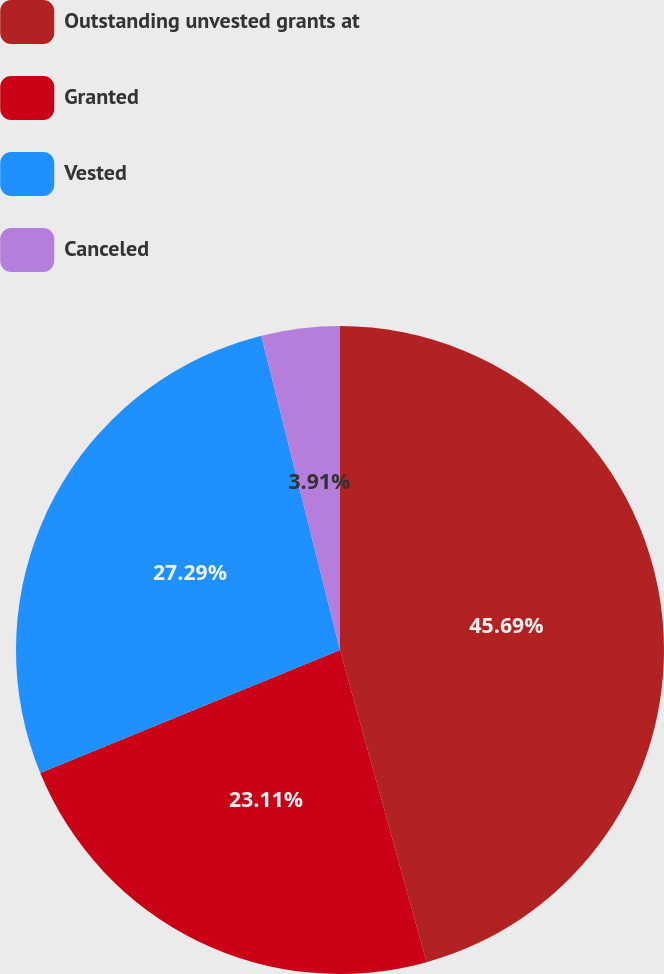Convert chart. <chart><loc_0><loc_0><loc_500><loc_500><pie_chart><fcel>Outstanding unvested grants at<fcel>Granted<fcel>Vested<fcel>Canceled<nl><fcel>45.7%<fcel>23.11%<fcel>27.29%<fcel>3.91%<nl></chart> 